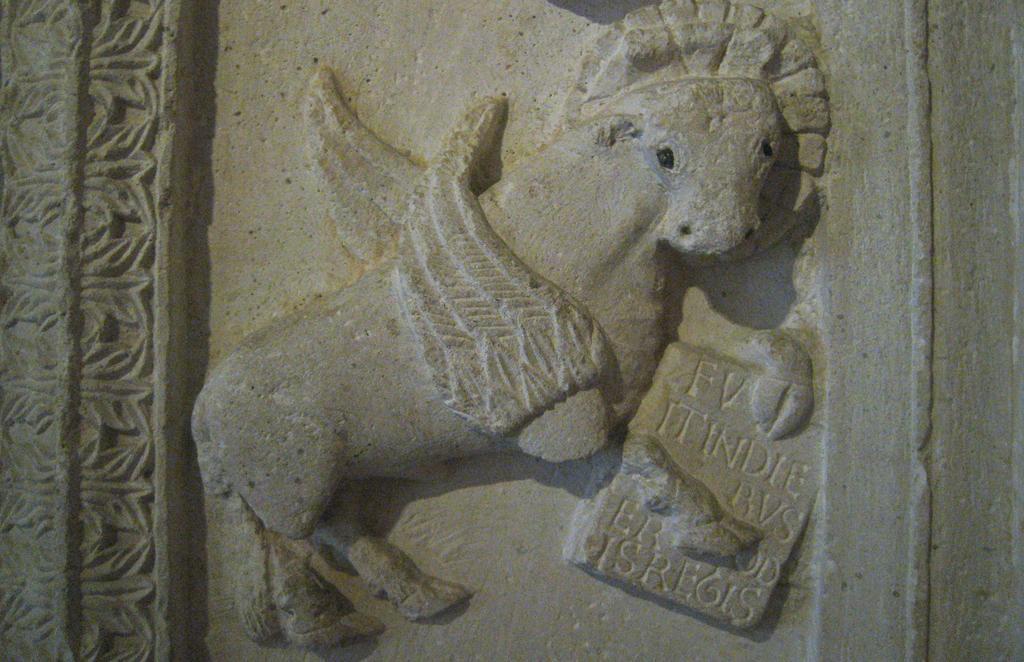Please provide a concise description of this image. In this image we can see carvings on the stone wall. 